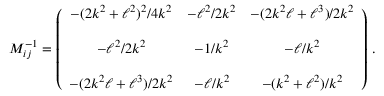Convert formula to latex. <formula><loc_0><loc_0><loc_500><loc_500>M _ { i j } ^ { - 1 } = \left ( \begin{array} { c c c } { { - ( 2 k ^ { 2 } + \ell ^ { 2 } ) ^ { 2 } / 4 k ^ { 2 } } } & { { - \ell ^ { 2 } / 2 k ^ { 2 } } } & { { - ( 2 k ^ { 2 } \ell + \ell ^ { 3 } ) / 2 k ^ { 2 } } } \\ { { - \ell ^ { 2 } / 2 k ^ { 2 } } } & { { - 1 / k ^ { 2 } } } & { { - \ell / k ^ { 2 } } } \\ { { - ( 2 k ^ { 2 } \ell + \ell ^ { 3 } ) / 2 k ^ { 2 } } } & { { - \ell / k ^ { 2 } } } & { { - ( k ^ { 2 } + \ell ^ { 2 } ) / k ^ { 2 } } } \end{array} \right ) \, .</formula> 